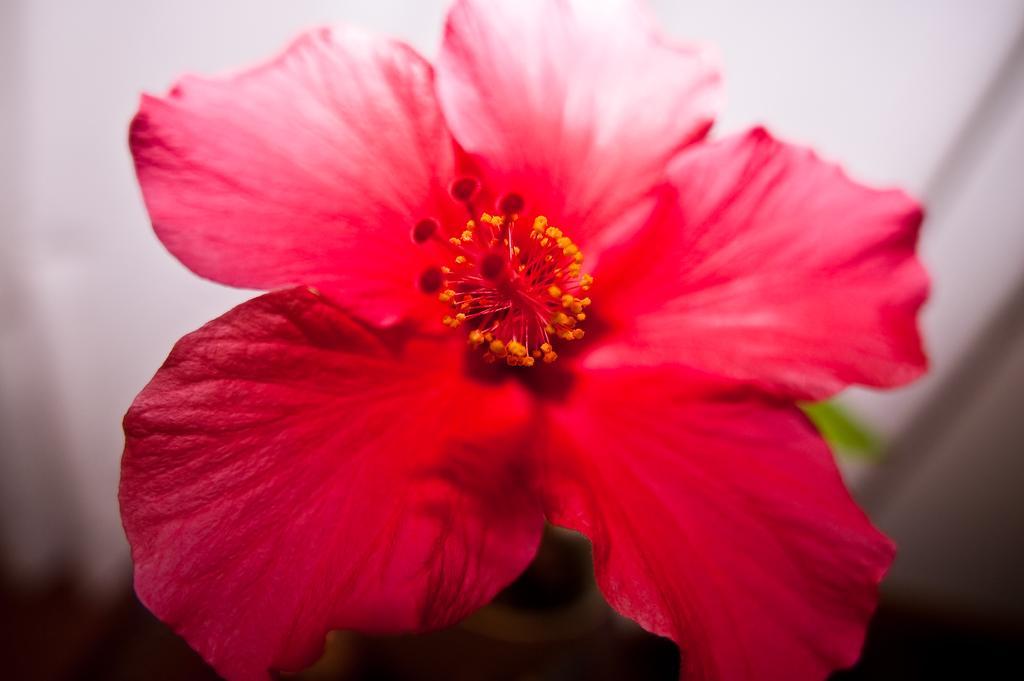Could you give a brief overview of what you see in this image? In the image we can see a flower, red in color and background is blurred. 